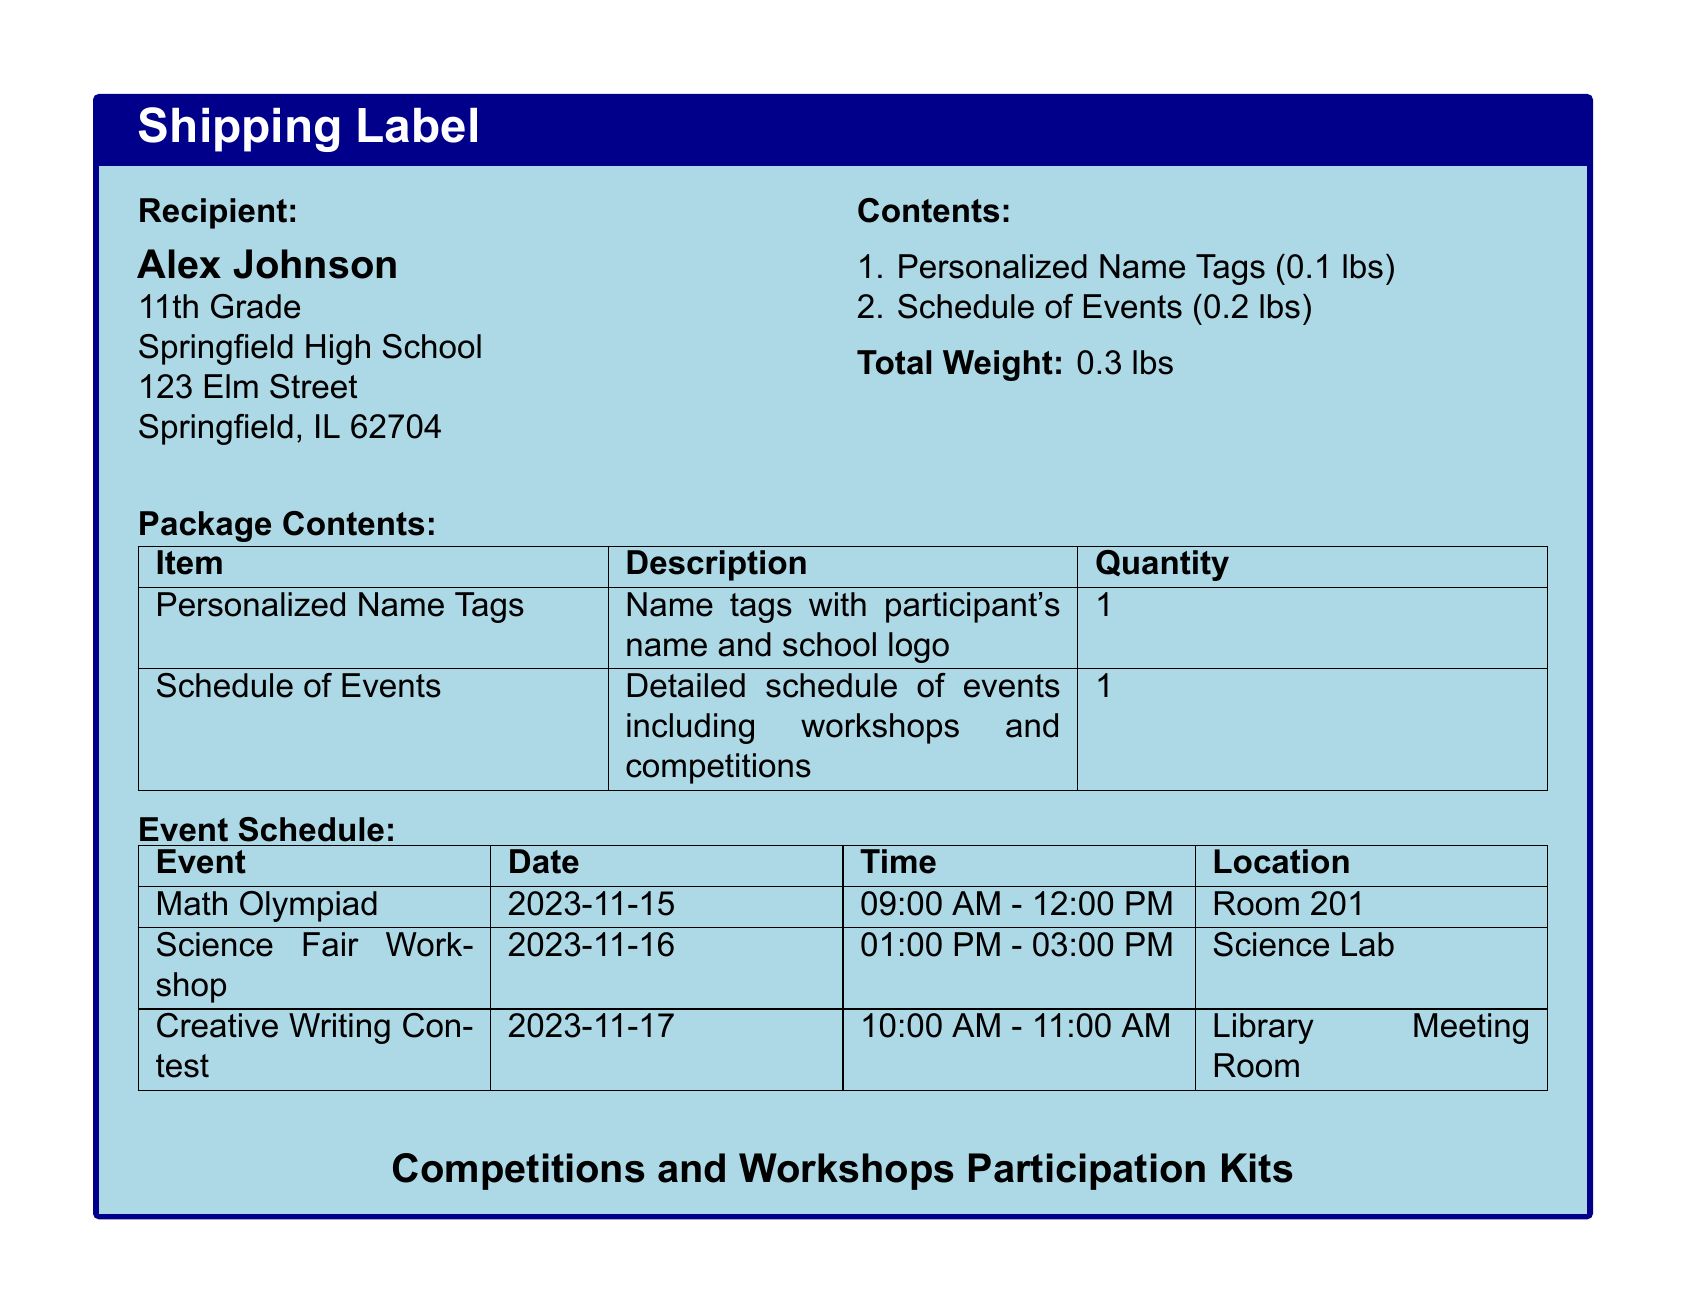What is the recipient's name? The recipient's name is stated at the beginning of the document under "Recipient."
Answer: Alex Johnson What is the total weight of the package? The total weight is mentioned in the "Contents" section of the document.
Answer: 0.3 lbs What event takes place on November 16, 2023? The document specifies the event scheduled for this date in the "Event Schedule" section.
Answer: Science Fair Workshop How many personalized name tags are included? The quantity of personalized name tags is listed in the "Package Contents" table.
Answer: 1 What time does the Math Olympiad start? This information is found in the "Event Schedule" table, which details the time for each event.
Answer: 09:00 AM What is included in the Participation Kits? The document outlines the contents in the "Contents" section and "Package Contents" table.
Answer: Personalized Name Tags and Schedule of Events Which room hosts the Creative Writing Contest? The specific location for this event is provided in the "Event Schedule" section.
Answer: Library Meeting Room How many events are listed in the document? By counting the events under the "Event Schedule," you can determine the total number of events.
Answer: 3 